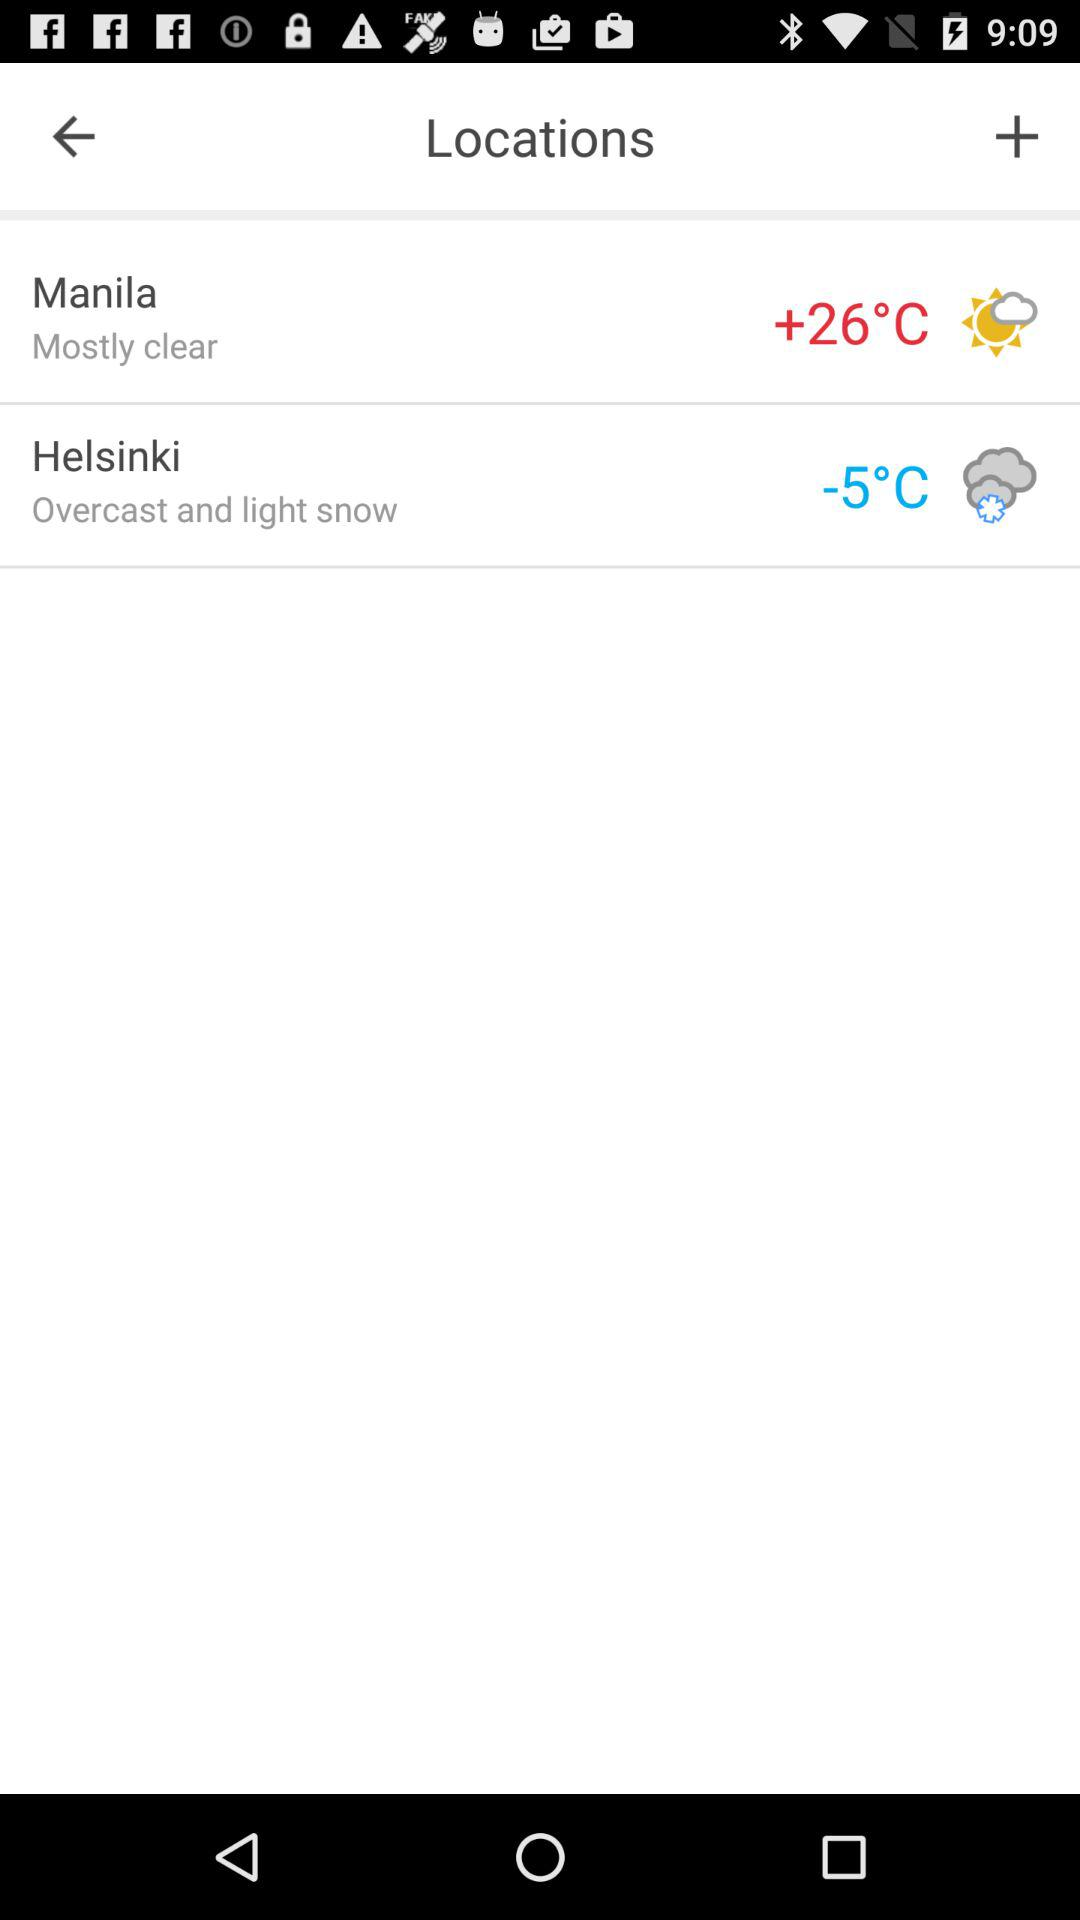What's the weather condition in Helsinki? The weather condition is overcast and light snow. 